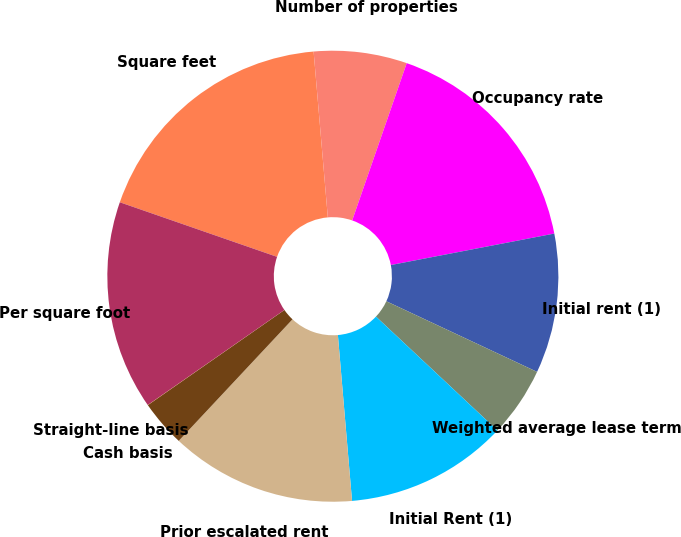<chart> <loc_0><loc_0><loc_500><loc_500><pie_chart><fcel>Square feet<fcel>Number of properties<fcel>Occupancy rate<fcel>Initial rent (1)<fcel>Weighted average lease term<fcel>Initial Rent (1)<fcel>Prior escalated rent<fcel>Cash basis<fcel>Straight-line basis<fcel>Per square foot<nl><fcel>18.32%<fcel>6.67%<fcel>16.66%<fcel>10.0%<fcel>5.01%<fcel>11.66%<fcel>13.33%<fcel>3.34%<fcel>0.01%<fcel>14.99%<nl></chart> 